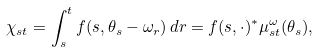Convert formula to latex. <formula><loc_0><loc_0><loc_500><loc_500>\chi _ { s t } = \int _ { s } ^ { t } f ( s , \theta _ { s } - \omega _ { r } ) \, d r = f ( s , \cdot ) ^ { * } \mu ^ { \omega } _ { s t } ( \theta _ { s } ) ,</formula> 